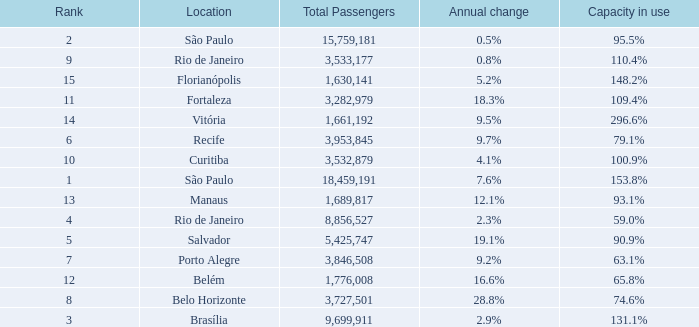What location has an annual change of 7.6% São Paulo. 